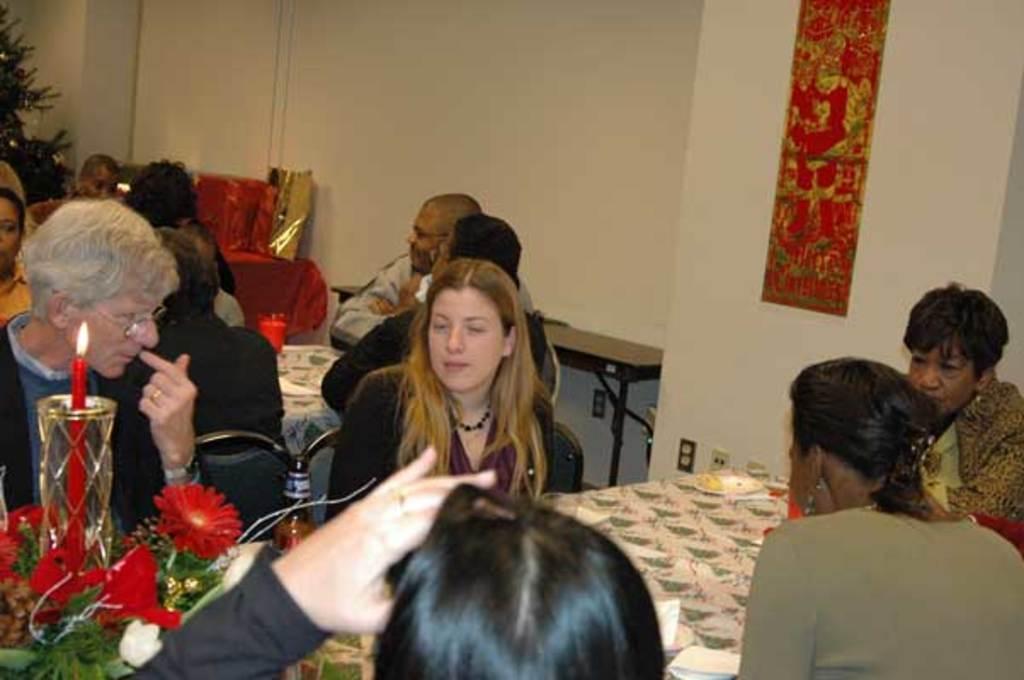In one or two sentences, can you explain what this image depicts? As we can see in the image there is wall, plant, group of people sitting on chairs and there are tables. On tables there are plates, tissues, candle and flowers. 